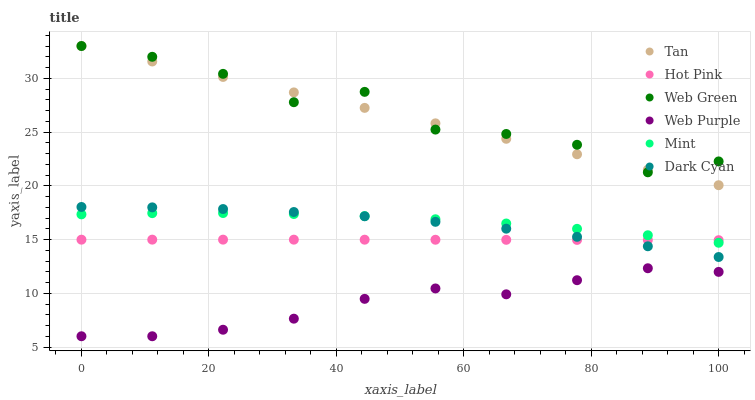Does Web Purple have the minimum area under the curve?
Answer yes or no. Yes. Does Web Green have the maximum area under the curve?
Answer yes or no. Yes. Does Web Green have the minimum area under the curve?
Answer yes or no. No. Does Web Purple have the maximum area under the curve?
Answer yes or no. No. Is Tan the smoothest?
Answer yes or no. Yes. Is Web Green the roughest?
Answer yes or no. Yes. Is Web Purple the smoothest?
Answer yes or no. No. Is Web Purple the roughest?
Answer yes or no. No. Does Web Purple have the lowest value?
Answer yes or no. Yes. Does Web Green have the lowest value?
Answer yes or no. No. Does Tan have the highest value?
Answer yes or no. Yes. Does Web Purple have the highest value?
Answer yes or no. No. Is Web Purple less than Mint?
Answer yes or no. Yes. Is Web Green greater than Dark Cyan?
Answer yes or no. Yes. Does Dark Cyan intersect Mint?
Answer yes or no. Yes. Is Dark Cyan less than Mint?
Answer yes or no. No. Is Dark Cyan greater than Mint?
Answer yes or no. No. Does Web Purple intersect Mint?
Answer yes or no. No. 